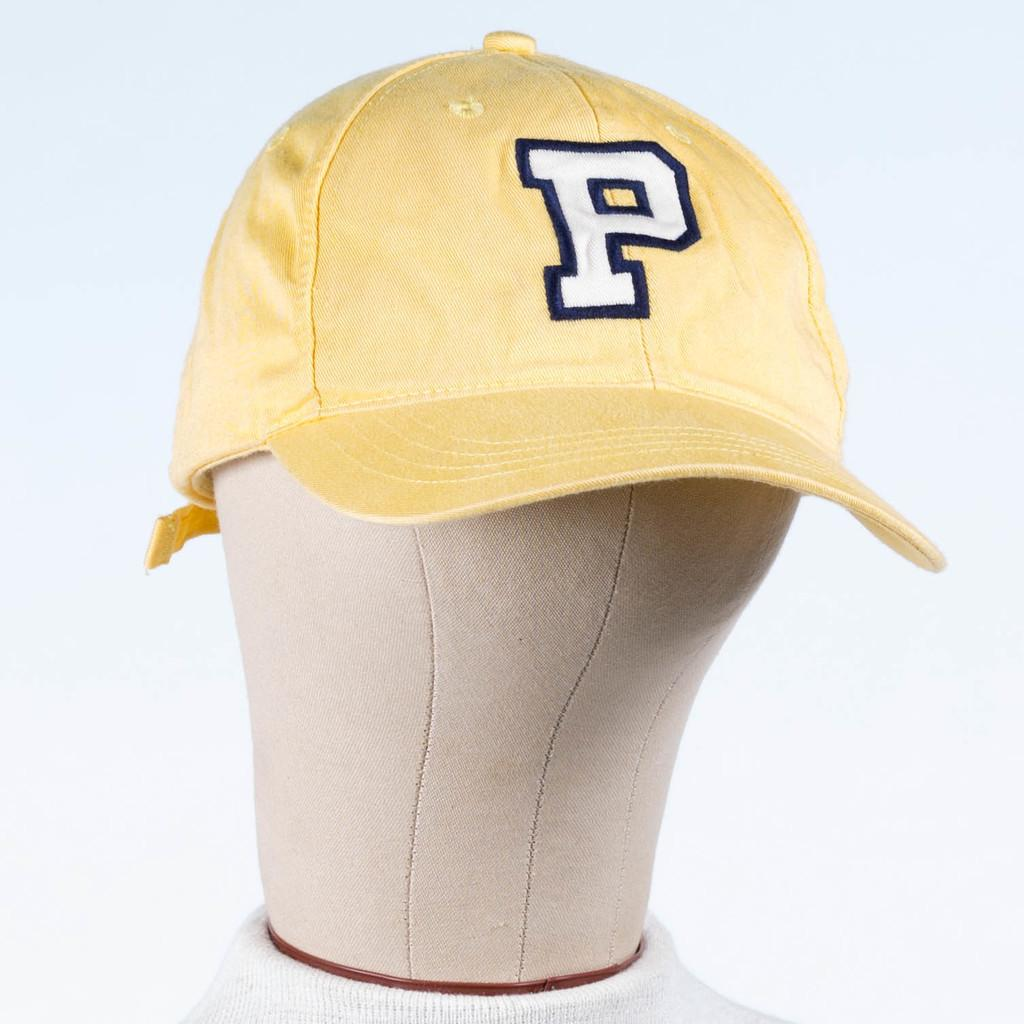What is the color of the cap in the image? The cap in the image is yellow. What is the cap placed on in the image? The yellow cap is on a mannequin. What is the color of the background in the image? The background of the image is white. How does the mannequin control the stick in the image? There is no stick present in the image, and the mannequin does not have the ability to control anything. How many times does the mannequin sneeze in the image? The mannequin does not have the ability to sneeze, as it is an inanimate object. 